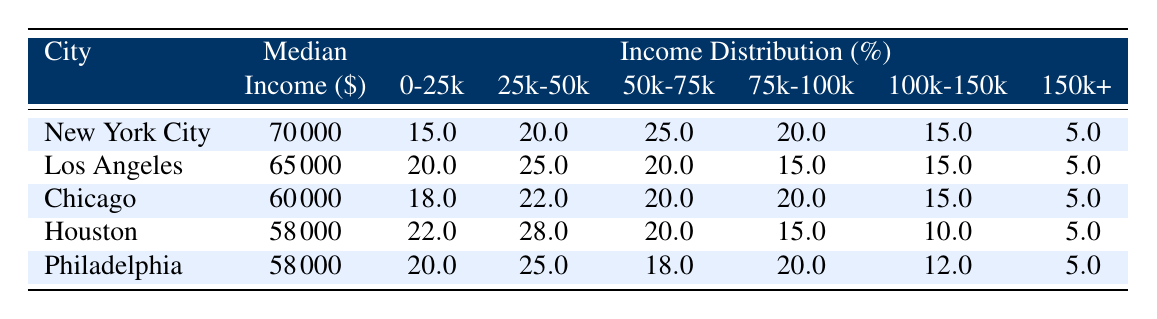What is the median income for New York City? The table shows the 'Median Income' for New York City as 70000.
Answer: 70000 Which city has the highest percentage of households earning between 25k and 50k? Looking at the 'Income Distribution (%)' column for the range 25k-50k across the cities, Houston has the highest percentage at 28.0.
Answer: Houston What is the total percentage of households in Los Angeles earning less than 50k? To find the total percentage of households in Los Angeles earning less than 50k, I will sum the percentages for the brackets 0-25k and 25k-50k: 20.0 + 25.0 = 45.0.
Answer: 45.0 Does Philadelphia have a higher median income than Houston? The median income for Philadelphia is 58000 and for Houston is also 58000. Therefore, neither city has a higher median income than the other.
Answer: No What percentage of households in Chicago earn 100k or more? The percentage of households in Chicago earning 100k or more is 15.0%, as indicated in the table under the column '100k-150k' and '150k+'.
Answer: 15.0 Which city has a higher total percentage of households earning more than 75k, New York City or Los Angeles? For New York City, the percentages for 75k-100k, 100k-150k, and 150k+ are 20.0, 15.0, and 5.0 respectively, summing to 40.0. For Los Angeles, the corresponding percentages are 15.0, 15.0, and 5.0, summing to 35.0. Since 40.0 is greater than 35.0, New York City has a higher total percentage.
Answer: New York City What is the median income difference between Chicago and Los Angeles? The median income for Chicago is 60000 and for Los Angeles is 65000. The difference is calculated as 65000 - 60000 = 5000.
Answer: 5000 Is it true that more than 20% of households in Houston earn between 25k and 50k? Looking at the data for Houston, 28.0% of households earn between 25k and 50k, which is indeed more than 20%.
Answer: Yes Which city has the lowest percentage of households earning 150k or more? The table indicates that all cities have 5.0% in the category of 150k or more. Therefore, no city uniquely has the lowest percentage; they are all tied.
Answer: All have the same percentage (5.0) 